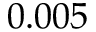Convert formula to latex. <formula><loc_0><loc_0><loc_500><loc_500>0 . 0 0 5</formula> 